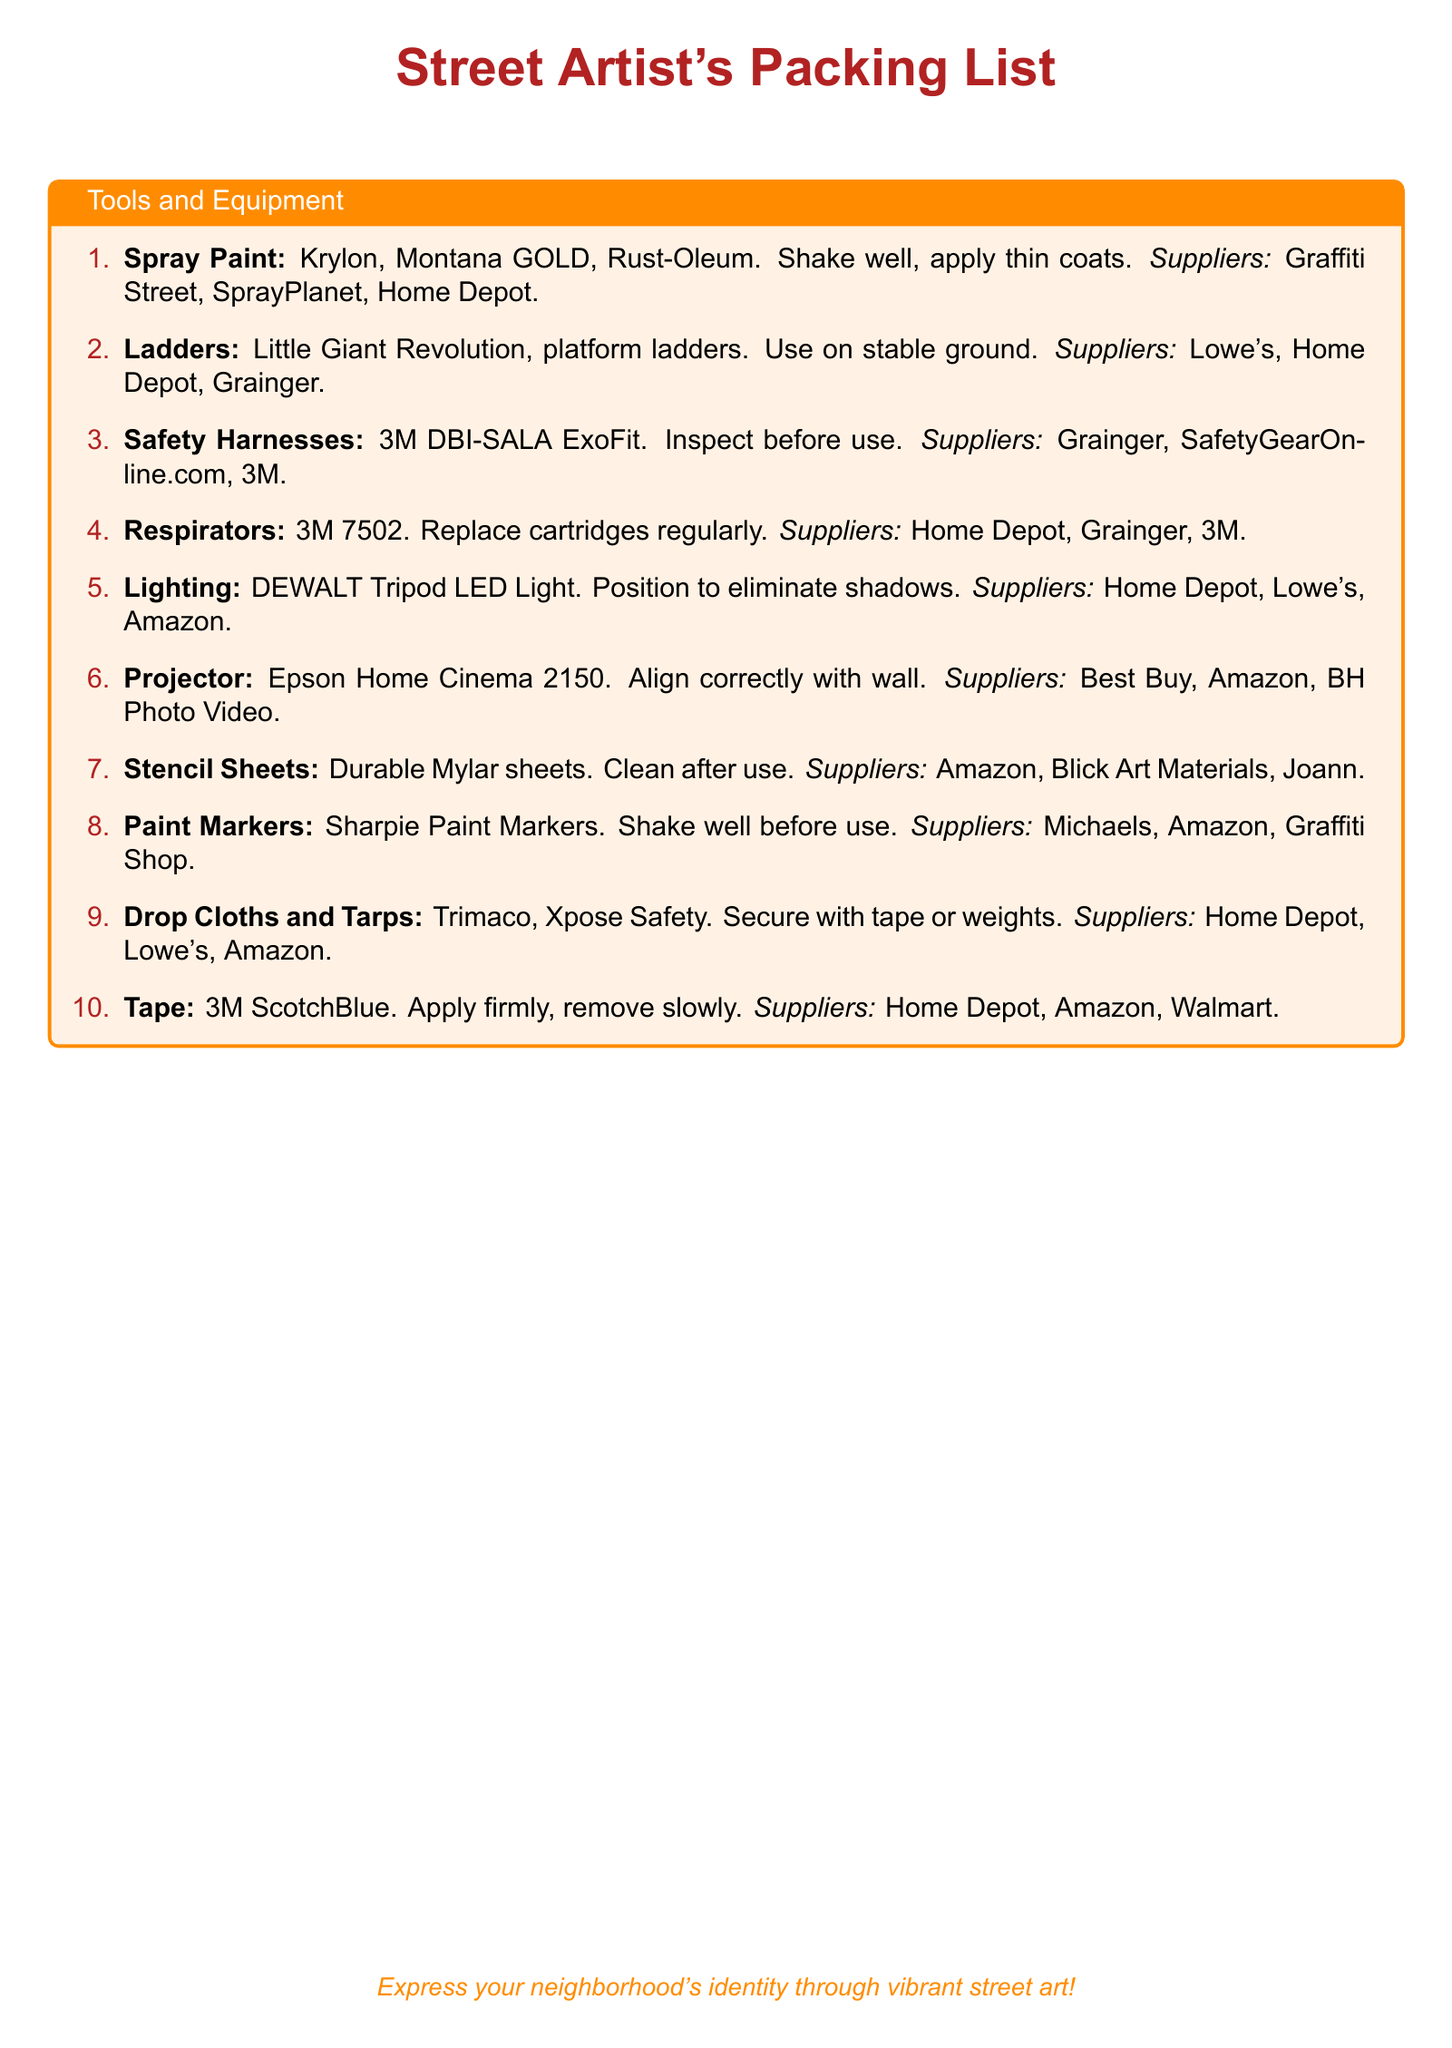What is the first item listed? The first item listed in the packing list is identified by the number one in the enumeration.
Answer: Spray Paint How many types of ladders are mentioned? The packing list specifies two types of ladders, which are mentioned in one item.
Answer: Two What should you do before using a safety harness? The usage guidelines state that the safety harness should be inspected prior to use.
Answer: Inspect Which supplier sells respirators? The document lists multiple suppliers for respirators, identifying at least one.
Answer: Home Depot What material are stencil sheets made of? The packing list describes the stencil sheets as being made of a specific durable material.
Answer: Mylar Why should you shake spray paint well? The packing list notes the reason for shaking spray paint before use as part of proper application.
Answer: For application What is the purpose of drop cloths and tarps? The packing list briefly describes how drop cloths and tarps should be used to ensure clean work.
Answer: Secure with tape or weights How should tape be removed? The usage guidelines advise a specific method for removing tape to avoid damage.
Answer: Remove slowly 